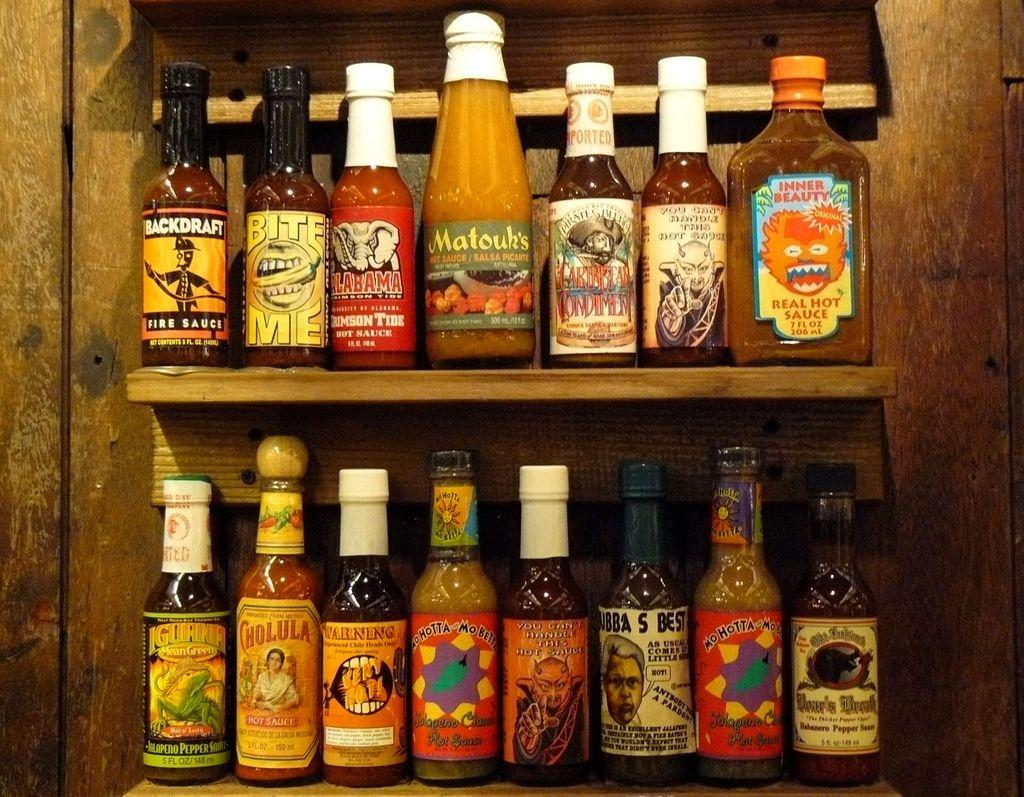What can be seen in the image that is used for storage? There is a shelf in the image that is used for storage. What items are stored on the shelf? There are bottles on the shelf. How are the bottles arranged on the shelf? The bottles are arranged in each shelf. Who is the soda expert in the image? There is no soda expert present in the image; it only shows a shelf with bottles. 